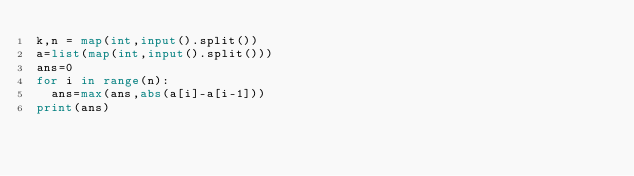Convert code to text. <code><loc_0><loc_0><loc_500><loc_500><_Python_>k,n = map(int,input().split())
a=list(map(int,input().split()))
ans=0
for i in range(n):
  ans=max(ans,abs(a[i]-a[i-1]))
print(ans)</code> 